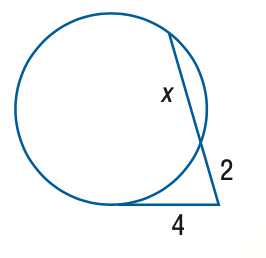Question: Find x to the nearest tenth. Assume that segments that appear to be tangent are tangent.
Choices:
A. 2
B. 4
C. 6
D. 8
Answer with the letter. Answer: C 